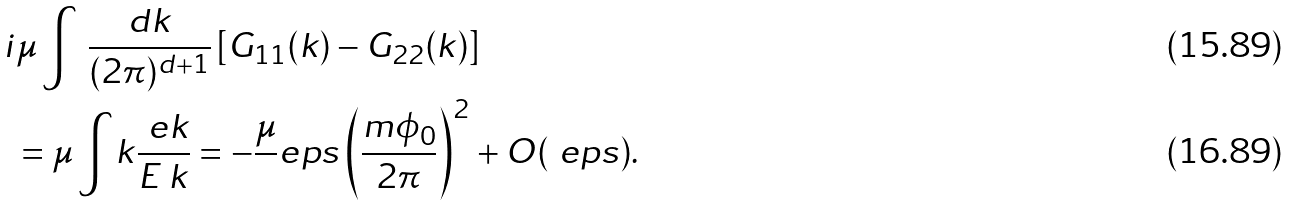Convert formula to latex. <formula><loc_0><loc_0><loc_500><loc_500>& i \mu \int \, \frac { d k } { ( 2 \pi ) ^ { d + 1 } } \left [ G _ { 1 1 } ( k ) - G _ { 2 2 } ( k ) \right ] \\ & \ = \mu \int _ { \ } k \frac { \ e k } { E _ { \ } k } = - \frac { \mu } { \ } e p s \left ( \frac { m \phi _ { 0 } } { 2 \pi } \right ) ^ { 2 } + O ( \ e p s ) .</formula> 